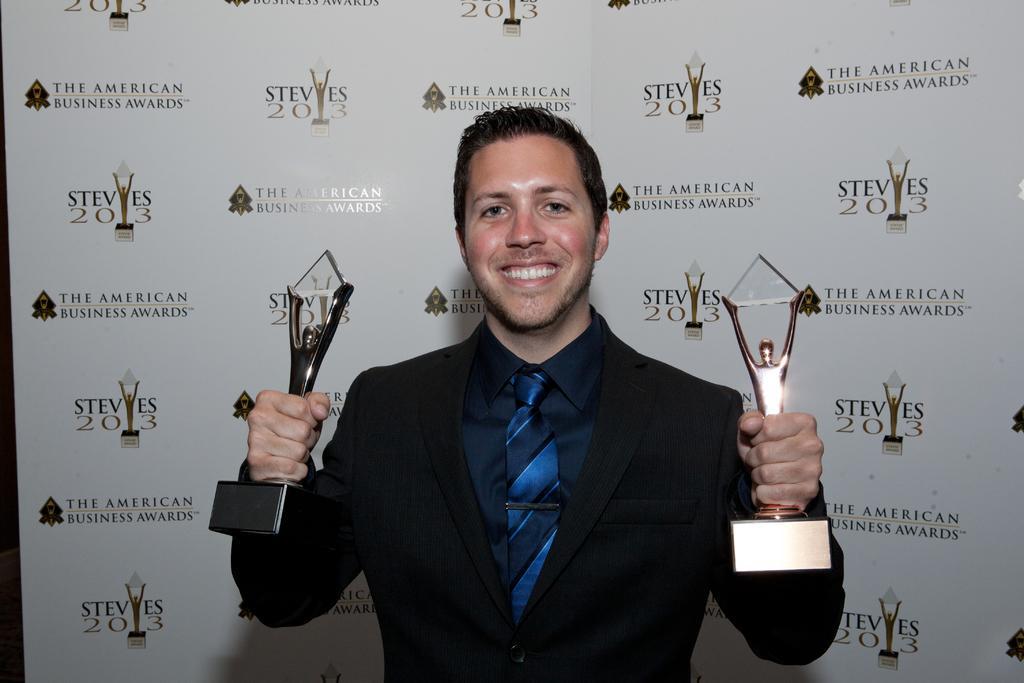Can you describe this image briefly? In this picture I can see a man smiling and holding two trophies, and in the background there is a board. 